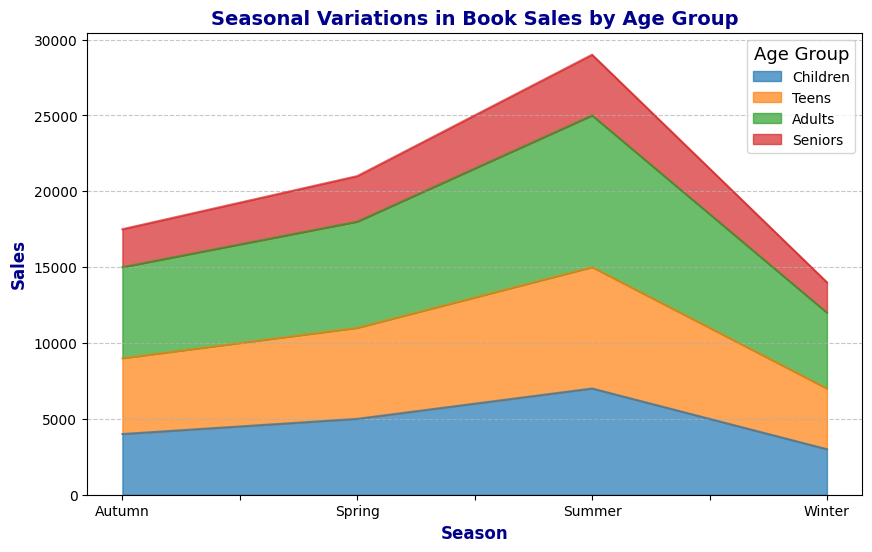What season shows the highest total book sales across all age groups? To find the season with the highest total book sales, sum the sales for each age group within each season and compare the totals. Winter: 3000+4000+5000+2000 = 14000, Spring: 5000+6000+7000+3000 = 21000, Summer: 7000+8000+10000+4000 = 29000, Autumn: 4000+5000+6000+2500 = 17500. Summer has the highest total sales.
Answer: Summer Which age group consistently sells the most books across all seasons? To determine the age group that sells the most books consistently, observe each segment's size for every season. The "Adults" age group has the largest areas in each season, indicating the highest sales.
Answer: Adults In which season do Seniors have the lowest sales? Look for the smallest area corresponding to "Seniors" in the figure. The smallest section for "Seniors" is in Autumn.
Answer: Autumn How do sales in Summer compare between Teens and Children? Compare the heights of the segments for Teens and Children in the Summer section. Teens have higher sales than Children in Summer, as the segment for Teens is above and taller than Children.
Answer: Teens have higher sales What are the total book sales in Winter for Adults and Seniors? Sum the sales for Adults and Seniors in Winter. Adults: 5000, Seniors: 2000. Total = 5000 + 2000 = 7000.
Answer: 7000 What's the difference in book sales between Spring and Autumn for the Children age group? Subtract the sales of Children in Autumn from those in Spring. Spring: 5000, Autumn: 4000. Difference = 5000 - 4000 = 1000.
Answer: 1000 Which age group has the smallest variation in sales throughout the seasons? Identify the age group where the difference between the highest and lowest sales is the smallest. "Seniors" vary from 2000 to 4000 (2000 difference), whereas other groups have larger ranges.
Answer: Seniors Rank the seasons from highest to lowest book sales for Teens. Evaluate the height of the "Teens" sections across different seasons and arrange them accordingly. Summer: 8000, Spring: 6000, Autumn: 5000, Winter: 4000. Ranks: Summer > Spring > Autumn > Winter.
Answer: Summer, Spring, Autumn, Winter Which season has the smallest difference in sales between Children and Teens? Calculate the sales difference for each season between Children and Teens: Winter: 4000-3000=1000, Spring: 6000-5000=1000, Summer: 8000-7000=1000, Autumn: 5000-4000=1000. All differences are equal.
Answer: All are equal In which season is the total book sales of Seniors the highest? Sum the sales of Seniors in each season: Winter: 2000, Spring: 3000, Summer: 4000, Autumn: 2500. The highest sales are in Summer.
Answer: Summer 